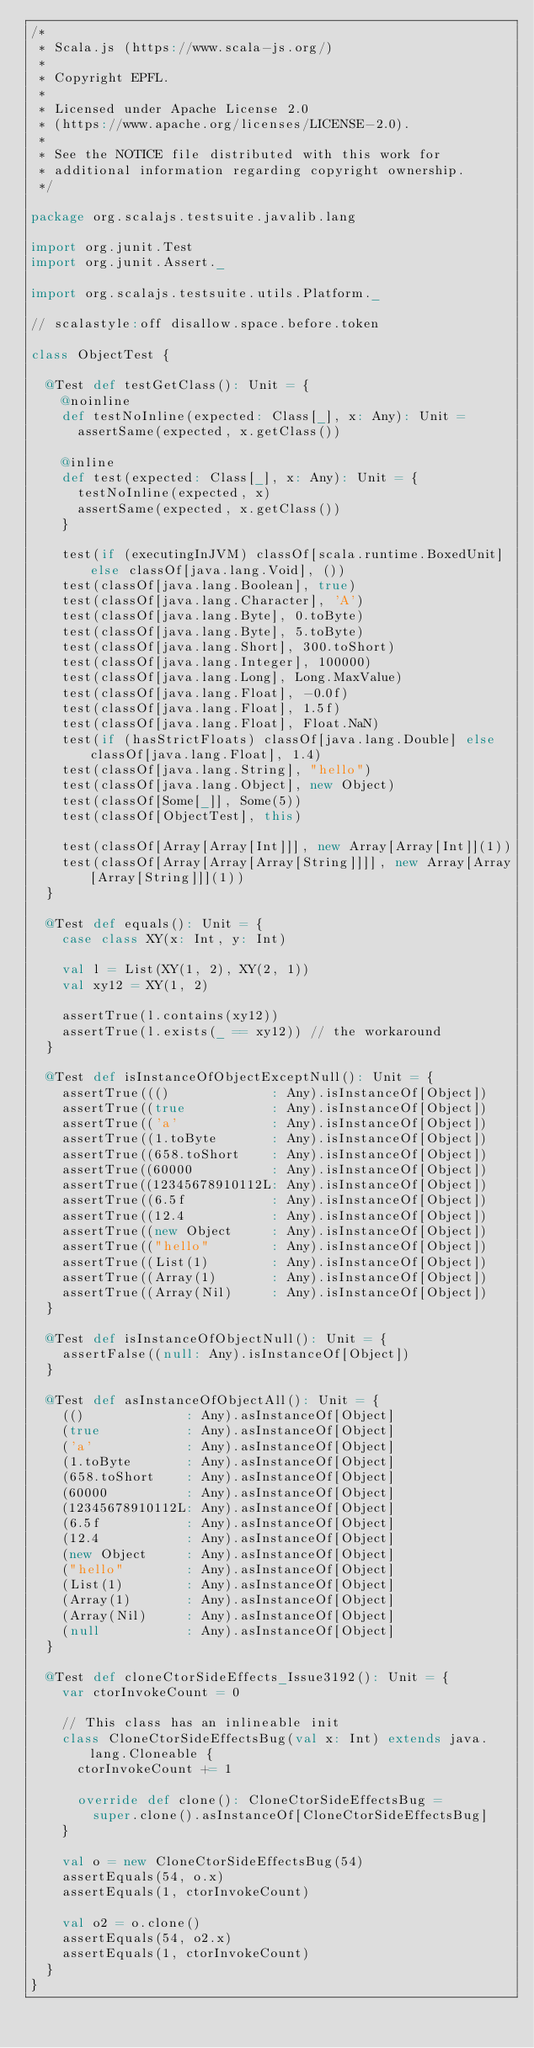<code> <loc_0><loc_0><loc_500><loc_500><_Scala_>/*
 * Scala.js (https://www.scala-js.org/)
 *
 * Copyright EPFL.
 *
 * Licensed under Apache License 2.0
 * (https://www.apache.org/licenses/LICENSE-2.0).
 *
 * See the NOTICE file distributed with this work for
 * additional information regarding copyright ownership.
 */

package org.scalajs.testsuite.javalib.lang

import org.junit.Test
import org.junit.Assert._

import org.scalajs.testsuite.utils.Platform._

// scalastyle:off disallow.space.before.token

class ObjectTest {

  @Test def testGetClass(): Unit = {
    @noinline
    def testNoInline(expected: Class[_], x: Any): Unit =
      assertSame(expected, x.getClass())

    @inline
    def test(expected: Class[_], x: Any): Unit = {
      testNoInline(expected, x)
      assertSame(expected, x.getClass())
    }

    test(if (executingInJVM) classOf[scala.runtime.BoxedUnit] else classOf[java.lang.Void], ())
    test(classOf[java.lang.Boolean], true)
    test(classOf[java.lang.Character], 'A')
    test(classOf[java.lang.Byte], 0.toByte)
    test(classOf[java.lang.Byte], 5.toByte)
    test(classOf[java.lang.Short], 300.toShort)
    test(classOf[java.lang.Integer], 100000)
    test(classOf[java.lang.Long], Long.MaxValue)
    test(classOf[java.lang.Float], -0.0f)
    test(classOf[java.lang.Float], 1.5f)
    test(classOf[java.lang.Float], Float.NaN)
    test(if (hasStrictFloats) classOf[java.lang.Double] else classOf[java.lang.Float], 1.4)
    test(classOf[java.lang.String], "hello")
    test(classOf[java.lang.Object], new Object)
    test(classOf[Some[_]], Some(5))
    test(classOf[ObjectTest], this)

    test(classOf[Array[Array[Int]]], new Array[Array[Int]](1))
    test(classOf[Array[Array[Array[String]]]], new Array[Array[Array[String]]](1))
  }

  @Test def equals(): Unit = {
    case class XY(x: Int, y: Int)

    val l = List(XY(1, 2), XY(2, 1))
    val xy12 = XY(1, 2)

    assertTrue(l.contains(xy12))
    assertTrue(l.exists(_ == xy12)) // the workaround
  }

  @Test def isInstanceOfObjectExceptNull(): Unit = {
    assertTrue((()             : Any).isInstanceOf[Object])
    assertTrue((true           : Any).isInstanceOf[Object])
    assertTrue(('a'            : Any).isInstanceOf[Object])
    assertTrue((1.toByte       : Any).isInstanceOf[Object])
    assertTrue((658.toShort    : Any).isInstanceOf[Object])
    assertTrue((60000          : Any).isInstanceOf[Object])
    assertTrue((12345678910112L: Any).isInstanceOf[Object])
    assertTrue((6.5f           : Any).isInstanceOf[Object])
    assertTrue((12.4           : Any).isInstanceOf[Object])
    assertTrue((new Object     : Any).isInstanceOf[Object])
    assertTrue(("hello"        : Any).isInstanceOf[Object])
    assertTrue((List(1)        : Any).isInstanceOf[Object])
    assertTrue((Array(1)       : Any).isInstanceOf[Object])
    assertTrue((Array(Nil)     : Any).isInstanceOf[Object])
  }

  @Test def isInstanceOfObjectNull(): Unit = {
    assertFalse((null: Any).isInstanceOf[Object])
  }

  @Test def asInstanceOfObjectAll(): Unit = {
    (()             : Any).asInstanceOf[Object]
    (true           : Any).asInstanceOf[Object]
    ('a'            : Any).asInstanceOf[Object]
    (1.toByte       : Any).asInstanceOf[Object]
    (658.toShort    : Any).asInstanceOf[Object]
    (60000          : Any).asInstanceOf[Object]
    (12345678910112L: Any).asInstanceOf[Object]
    (6.5f           : Any).asInstanceOf[Object]
    (12.4           : Any).asInstanceOf[Object]
    (new Object     : Any).asInstanceOf[Object]
    ("hello"        : Any).asInstanceOf[Object]
    (List(1)        : Any).asInstanceOf[Object]
    (Array(1)       : Any).asInstanceOf[Object]
    (Array(Nil)     : Any).asInstanceOf[Object]
    (null           : Any).asInstanceOf[Object]
  }

  @Test def cloneCtorSideEffects_Issue3192(): Unit = {
    var ctorInvokeCount = 0

    // This class has an inlineable init
    class CloneCtorSideEffectsBug(val x: Int) extends java.lang.Cloneable {
      ctorInvokeCount += 1

      override def clone(): CloneCtorSideEffectsBug =
        super.clone().asInstanceOf[CloneCtorSideEffectsBug]
    }

    val o = new CloneCtorSideEffectsBug(54)
    assertEquals(54, o.x)
    assertEquals(1, ctorInvokeCount)

    val o2 = o.clone()
    assertEquals(54, o2.x)
    assertEquals(1, ctorInvokeCount)
  }
}
</code> 